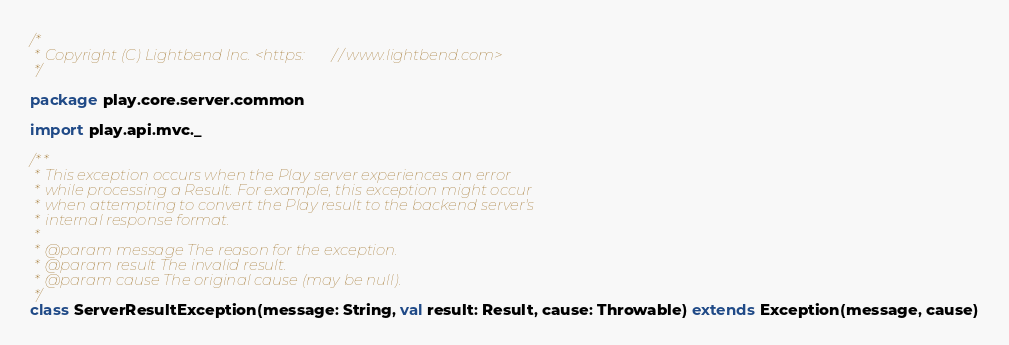<code> <loc_0><loc_0><loc_500><loc_500><_Scala_>/*
 * Copyright (C) Lightbend Inc. <https://www.lightbend.com>
 */

package play.core.server.common

import play.api.mvc._

/**
 * This exception occurs when the Play server experiences an error
 * while processing a Result. For example, this exception might occur
 * when attempting to convert the Play result to the backend server's
 * internal response format.
 *
 * @param message The reason for the exception.
 * @param result The invalid result.
 * @param cause The original cause (may be null).
 */
class ServerResultException(message: String, val result: Result, cause: Throwable) extends Exception(message, cause)
</code> 